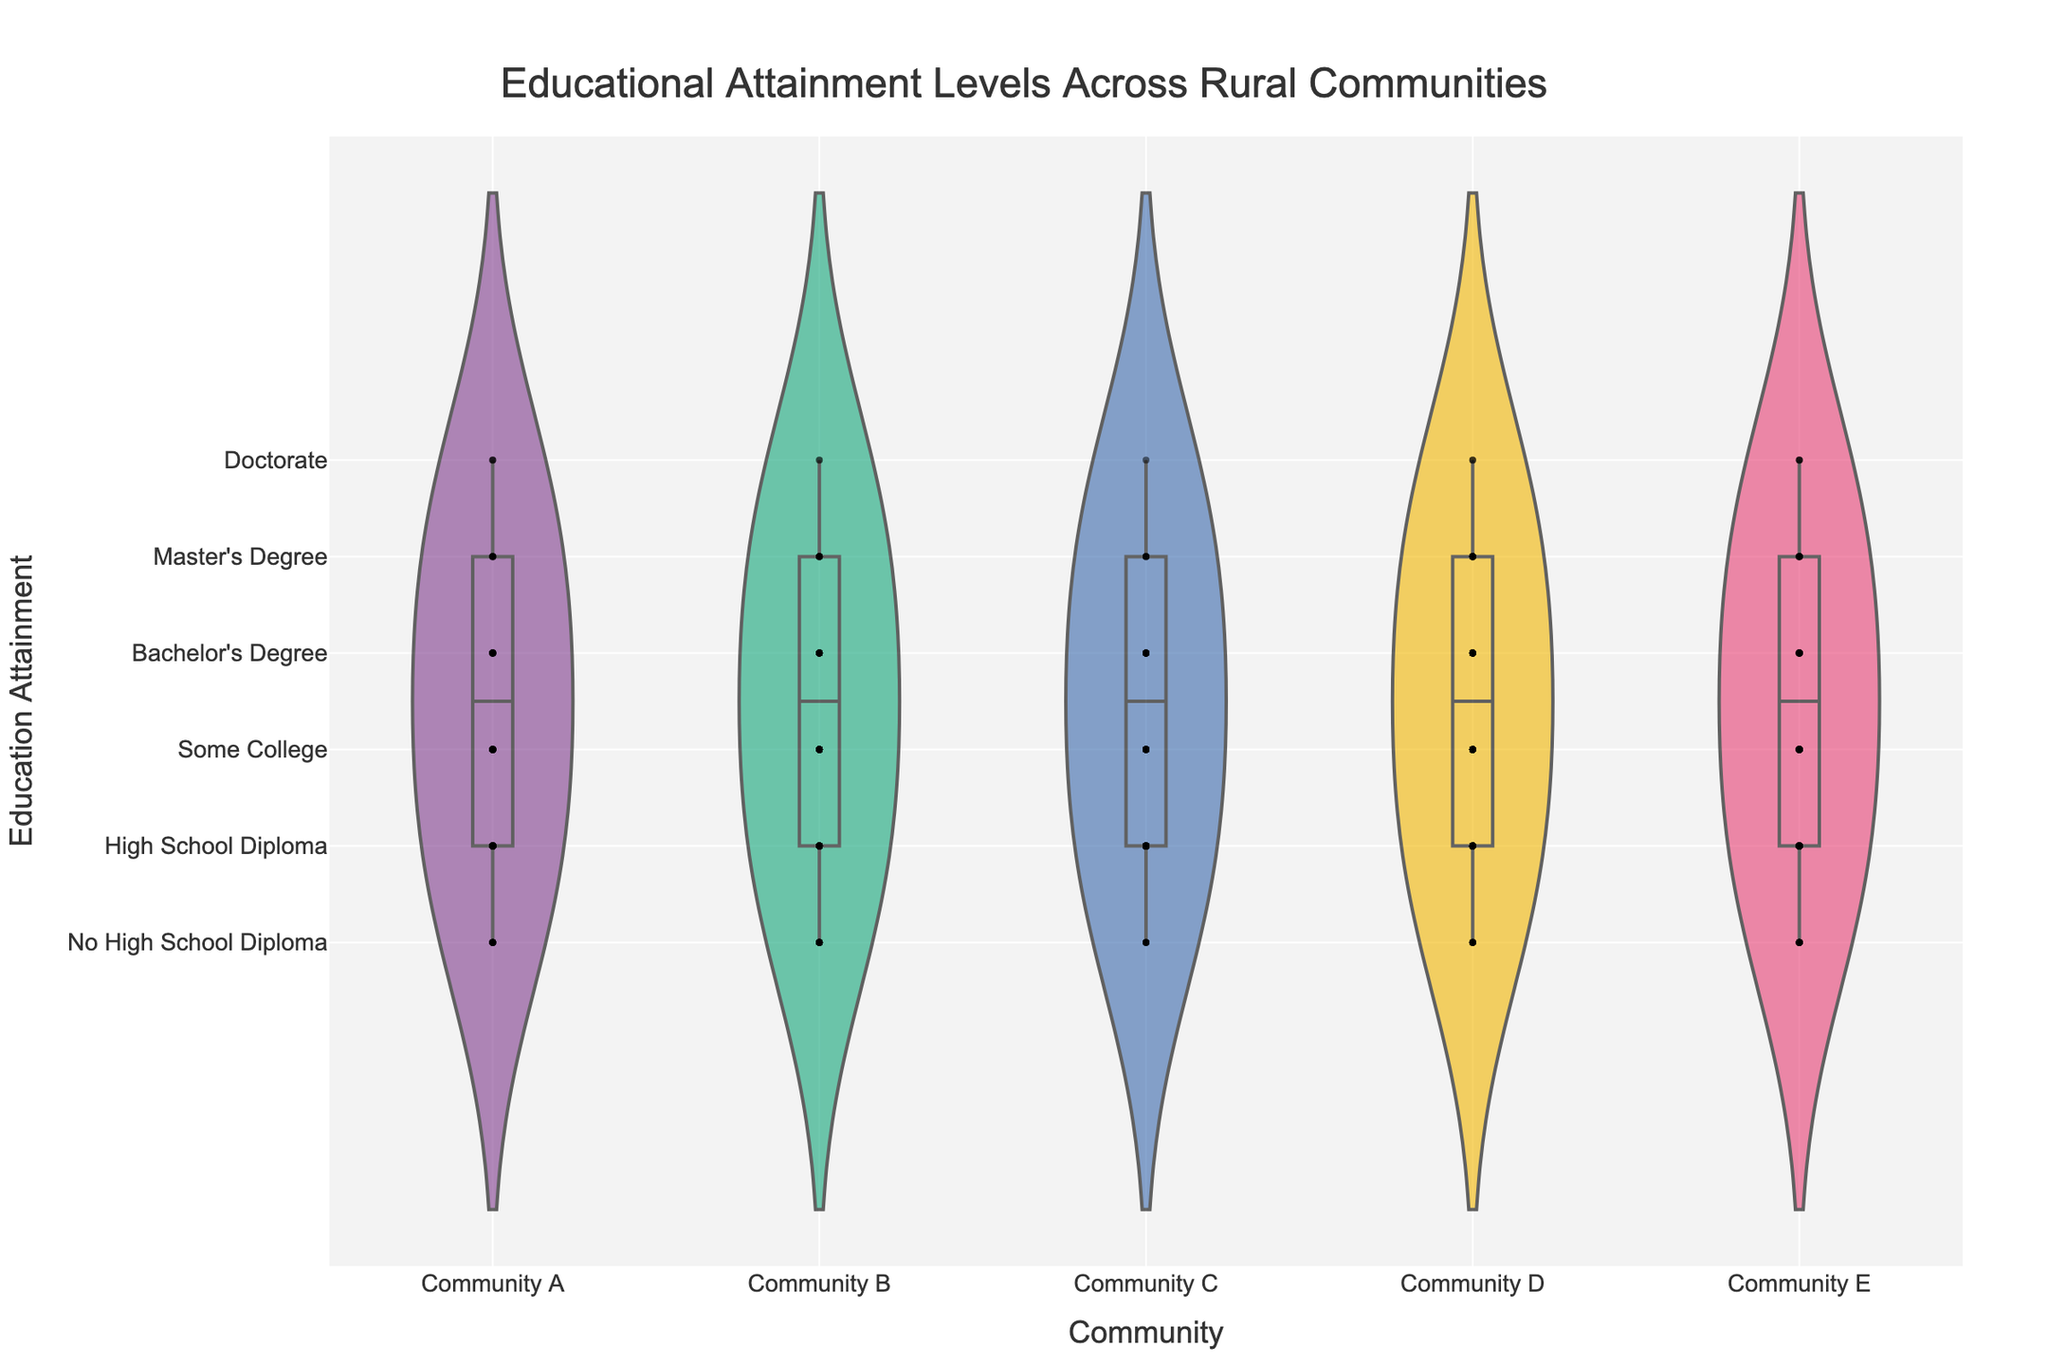What is the title of the figure? The title is located at the top center of the figure and reads, "Educational Attainment Levels Across Rural Communities."
Answer: Educational Attainment Levels Across Rural Communities How many different educational attainment levels are displayed in the figure? By examining the y-axis, we can see there are 6 distinct levels of educational attainment listed.
Answer: 6 Which community has the highest number of individuals with a high school diploma? By looking at the y-level "High School Diploma" across all communities, Community C has the highest density and count in the violin plot.
Answer: Community C What is the least common educational attainment level in Community D? The violin plot for Community D shows that the "Doctorate" level has the smallest band, indicating it is the least common.
Answer: Doctorate How do the educational attainment levels in Community A and Community E compare? By comparing the violin plots and jittered points for both communities across all educational levels, we observe that both have a somewhat similar distribution, but Community E shows slightly higher counts for "Master's Degree" and "Doctorate" levels.
Answer: Slightly higher counts at higher levels in Community E Which community has the most diverse range of educational attainment levels? Community D's violin plot is the widest across almost all education levels, indicating a greater diversity in educational attainment.
Answer: Community D What is the approximate median educational attainment level in Community B? The violin plot for Community B has a central line indicating the mean and box underneath showing the distribution. Most individuals fall around the "High School Diploma" and "Some College" levels, suggesting the median is "High School Diploma."
Answer: High School Diploma Are there more individuals with "No High School Diploma" in Community B or Community E? The violin plots for both communities show larger widths at the "No High School Diploma" level, but Community B's plot is wider, indicating a higher count.
Answer: Community B What is the difference in the number of individuals with bachelor's degrees between Community C and Community A? By comparing the widths of the violin plots for the "Bachelor's Degree" level in both communities, we see Community C has 25 individuals while Community A has 20. The difference is 25 - 20 = 5.
Answer: 5 